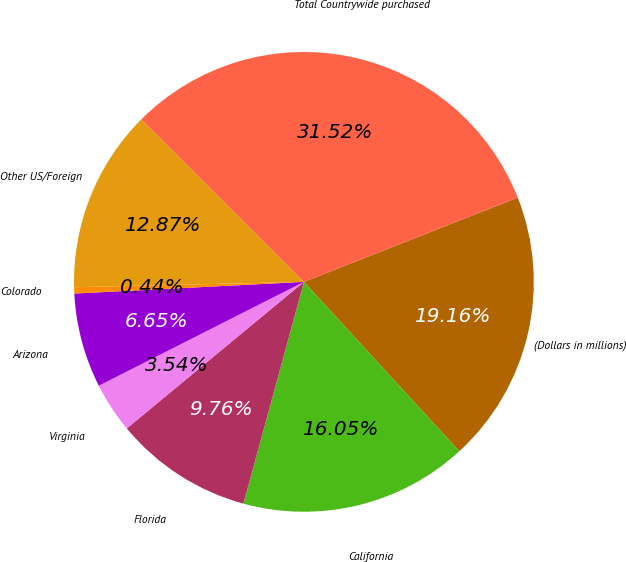Convert chart. <chart><loc_0><loc_0><loc_500><loc_500><pie_chart><fcel>(Dollars in millions)<fcel>California<fcel>Florida<fcel>Virginia<fcel>Arizona<fcel>Colorado<fcel>Other US/Foreign<fcel>Total Countrywide purchased<nl><fcel>19.16%<fcel>16.05%<fcel>9.76%<fcel>3.54%<fcel>6.65%<fcel>0.44%<fcel>12.87%<fcel>31.52%<nl></chart> 